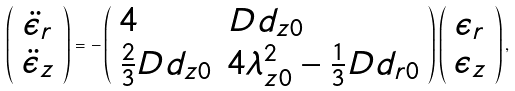Convert formula to latex. <formula><loc_0><loc_0><loc_500><loc_500>\left ( \begin{array} { c } \ddot { \epsilon } _ { r } \\ \ddot { \epsilon } _ { z } \end{array} \right ) = - \left ( \begin{array} { l l } 4 & D d _ { z 0 } \\ \frac { 2 } { 3 } D d _ { z 0 } & 4 \lambda _ { z 0 } ^ { 2 } - \frac { 1 } { 3 } D d _ { r 0 } \end{array} \right ) \left ( \begin{array} { c } \epsilon _ { r } \\ \epsilon _ { z } \\ \end{array} \right ) ,</formula> 